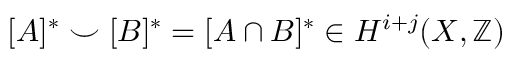<formula> <loc_0><loc_0><loc_500><loc_500>[ A ] ^ { * } \smile [ B ] ^ { * } = [ A \cap B ] ^ { * } \in H ^ { i + j } ( X , \mathbb { Z } )</formula> 